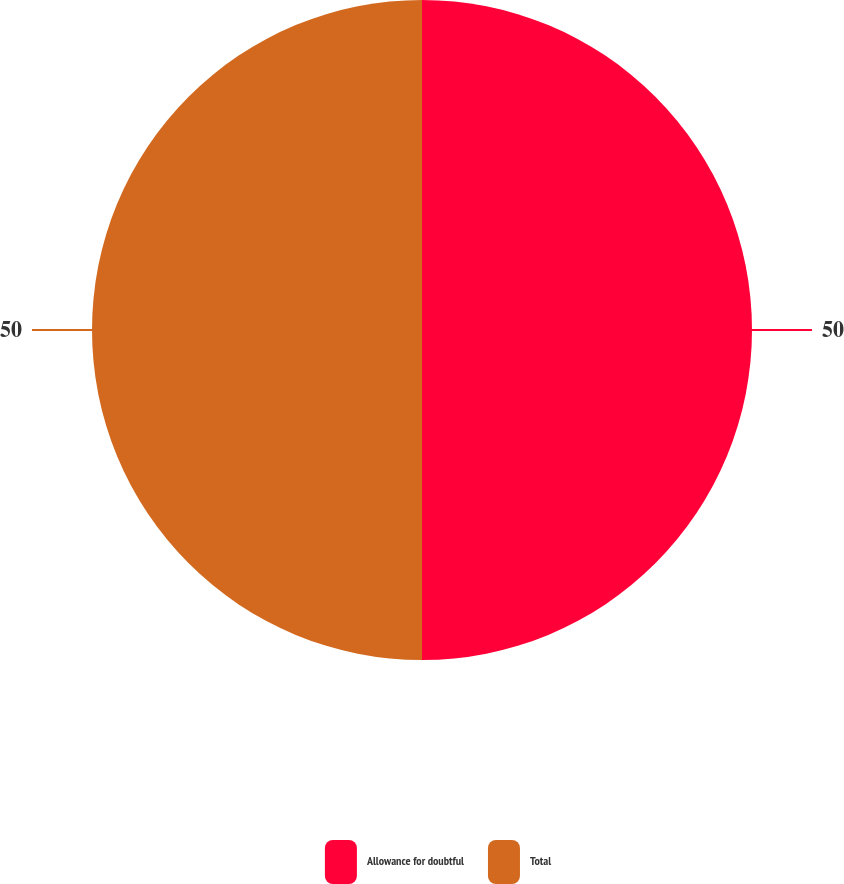Convert chart. <chart><loc_0><loc_0><loc_500><loc_500><pie_chart><fcel>Allowance for doubtful<fcel>Total<nl><fcel>50.0%<fcel>50.0%<nl></chart> 